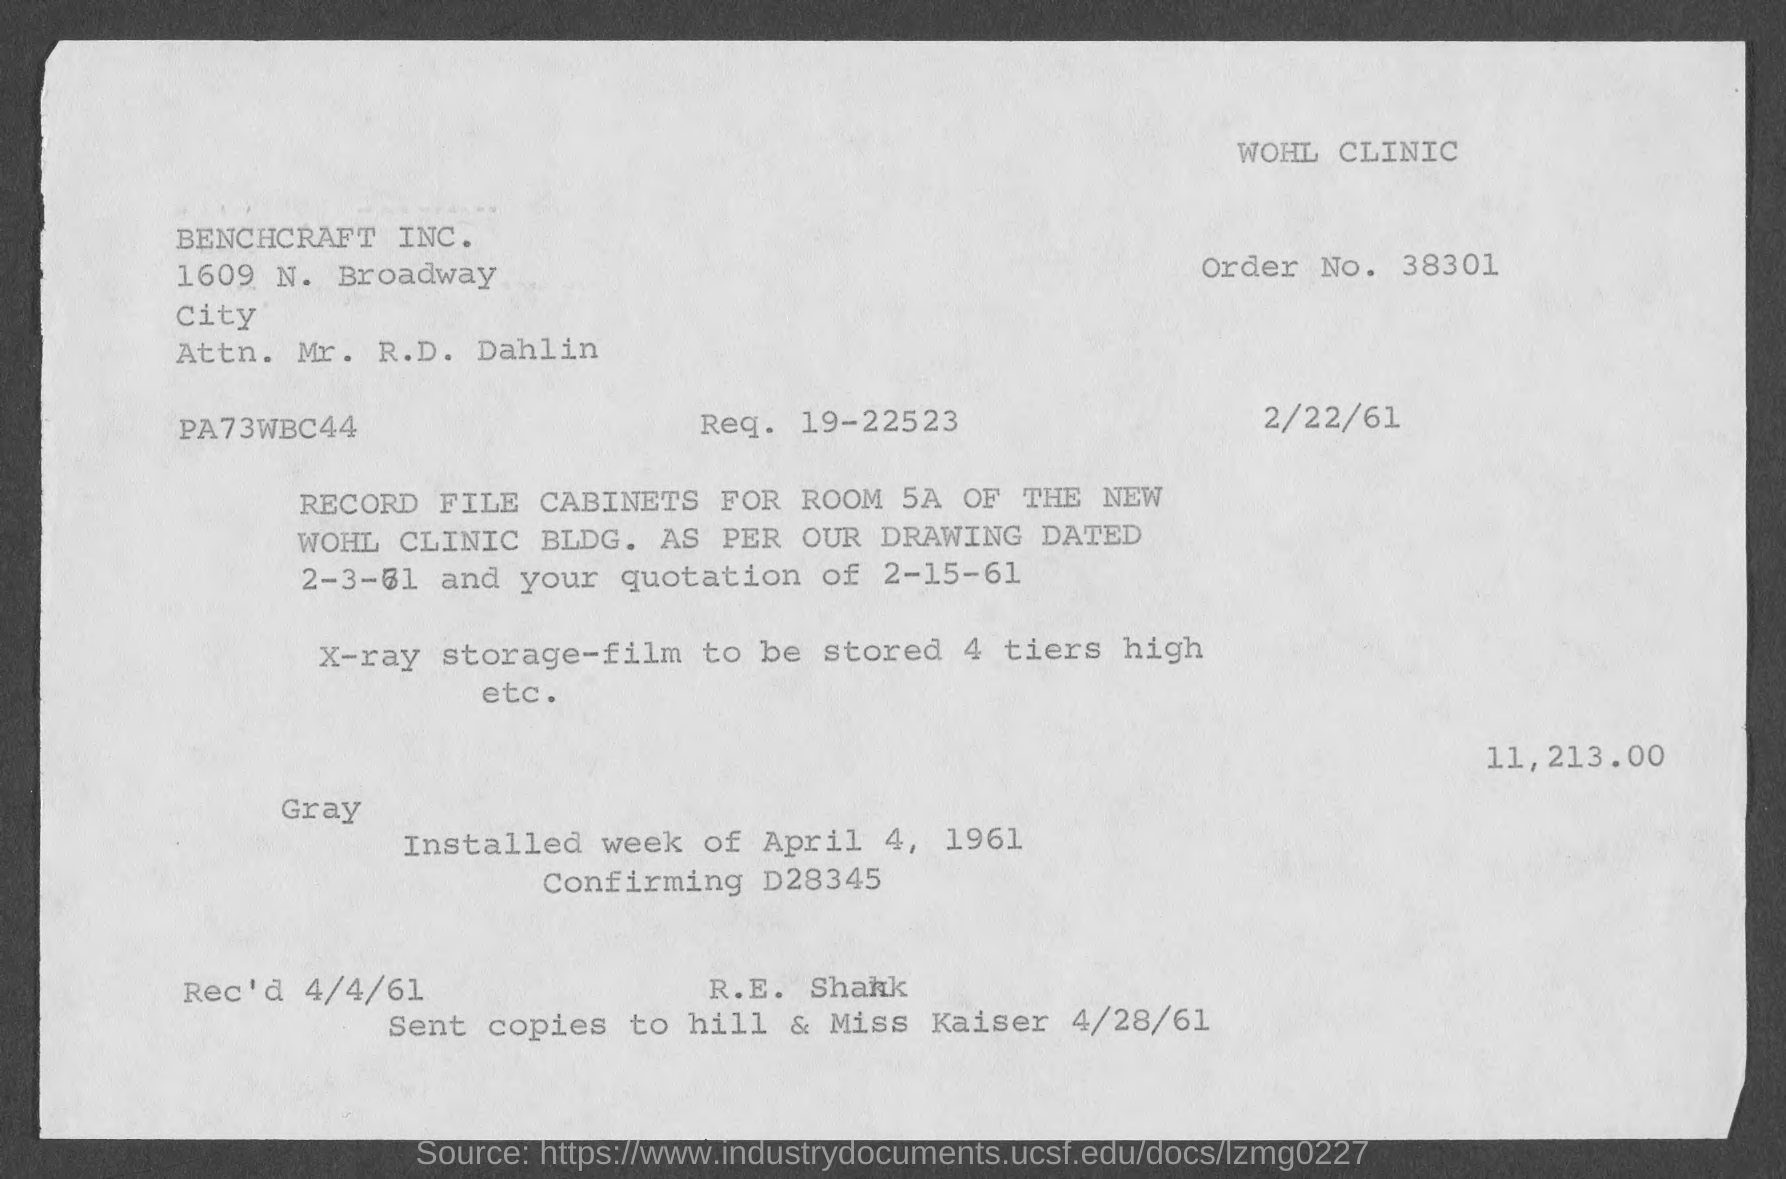Identify some key points in this picture. The order number is 38301... What is Request No. 19-22523...?" is a request for information or a request for action. The bill indicates that the date is February 22nd, 1961. 